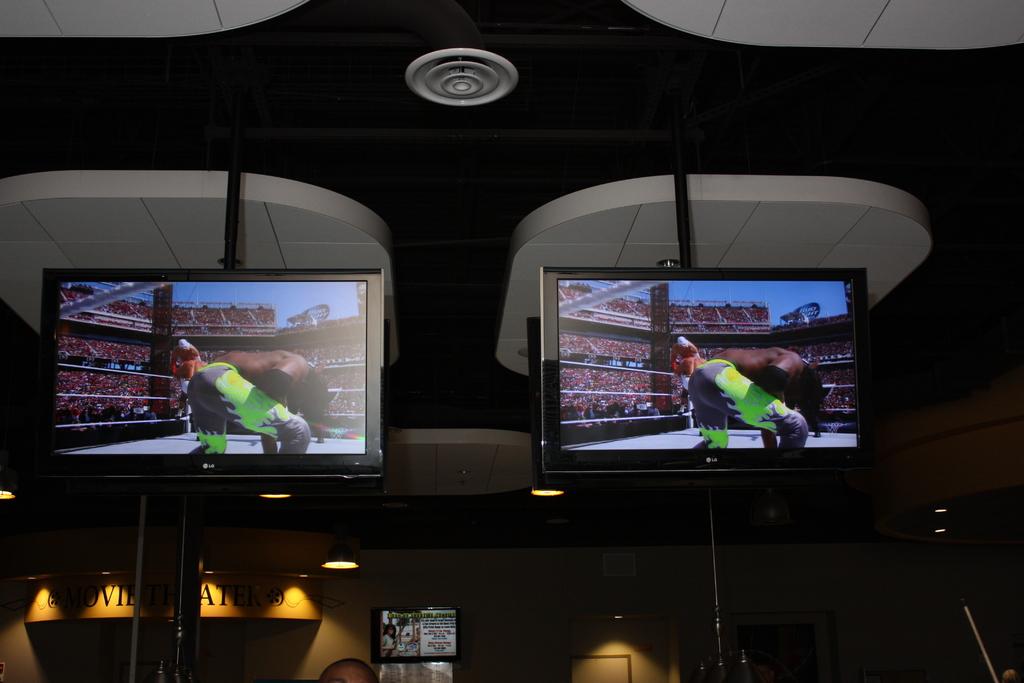What kind of theater is in the background?
Provide a short and direct response. Movie. 